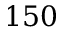<formula> <loc_0><loc_0><loc_500><loc_500>1 5 0</formula> 